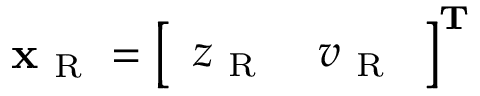Convert formula to latex. <formula><loc_0><loc_0><loc_500><loc_500>x _ { R } = \left [ \begin{array} { l l } { z _ { R } } & { v _ { R } } \end{array} \right ] ^ { T }</formula> 